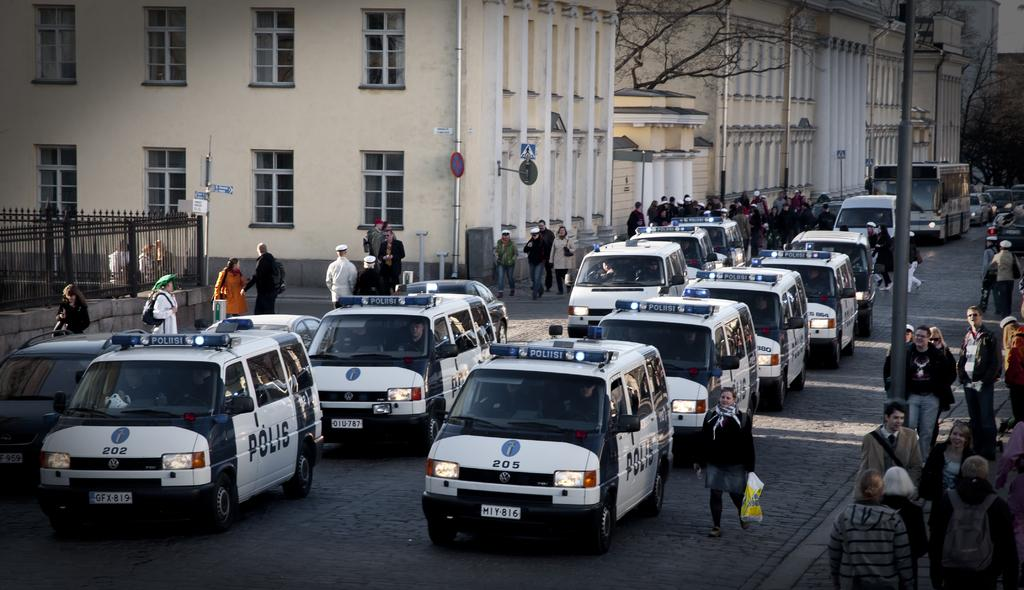Provide a one-sentence caption for the provided image. Polis cars that are lined on the street. 